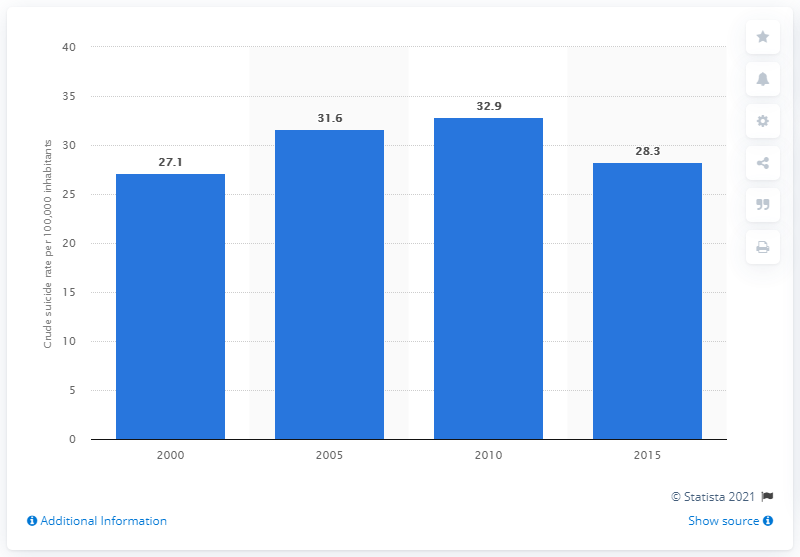Specify some key components in this picture. In 2015, the crude suicide rate in Mongolia was 28.3 per 100,000 population. 